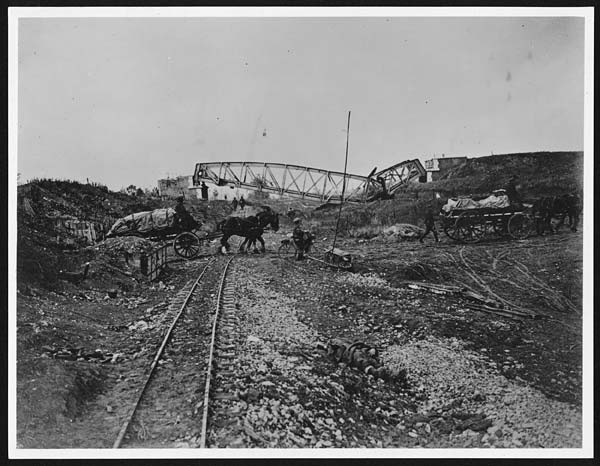What are some prominent features in the image besides the horse? Besides the horse, the image prominently features a broken bridge, horse carriages, people crossing a railroad track, and workers involved in constructing the railway. These elements suggest a bustling scene focused on the development of transportation infrastructure. 